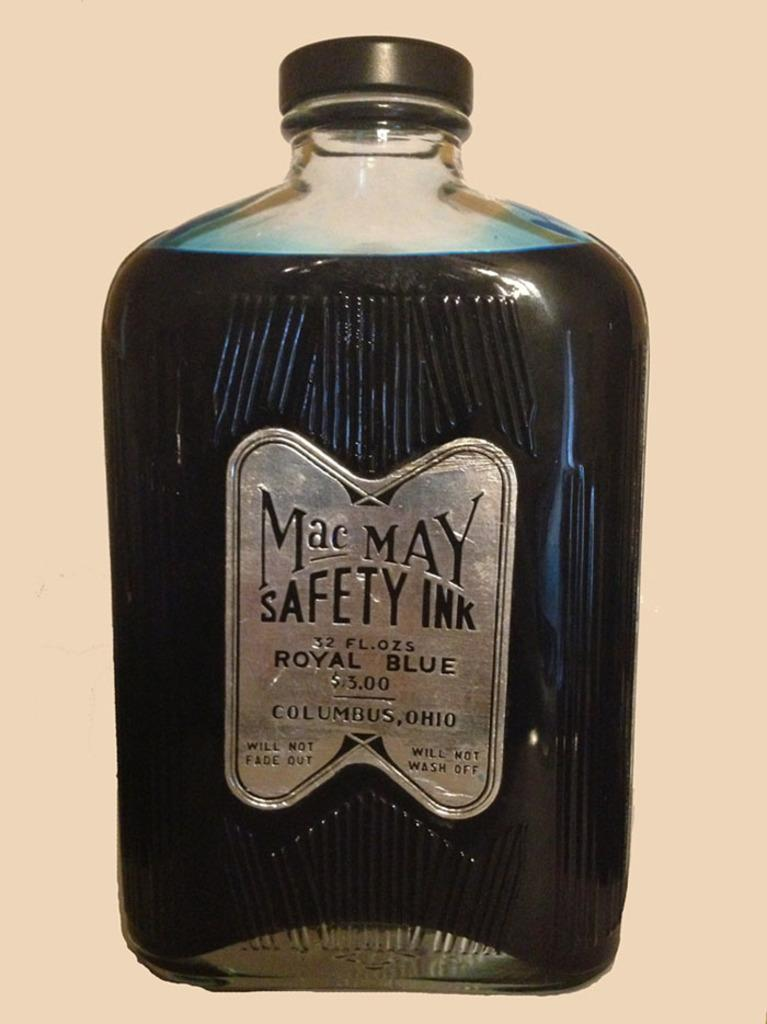<image>
Write a terse but informative summary of the picture. A clear bottle of mac may safety ink in royal blue. 